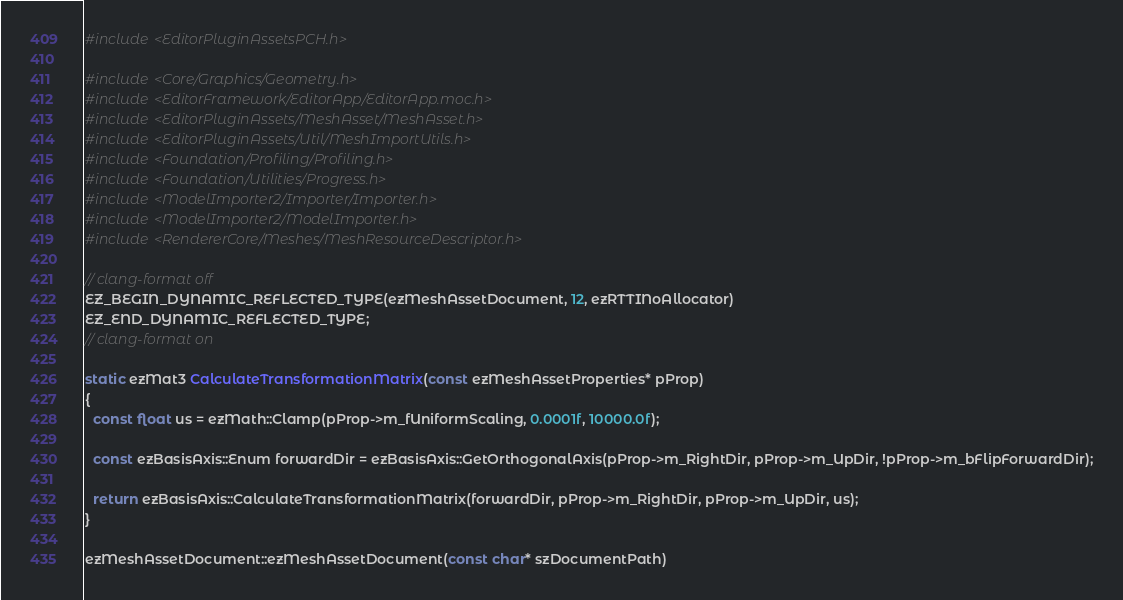<code> <loc_0><loc_0><loc_500><loc_500><_C++_>#include <EditorPluginAssetsPCH.h>

#include <Core/Graphics/Geometry.h>
#include <EditorFramework/EditorApp/EditorApp.moc.h>
#include <EditorPluginAssets/MeshAsset/MeshAsset.h>
#include <EditorPluginAssets/Util/MeshImportUtils.h>
#include <Foundation/Profiling/Profiling.h>
#include <Foundation/Utilities/Progress.h>
#include <ModelImporter2/Importer/Importer.h>
#include <ModelImporter2/ModelImporter.h>
#include <RendererCore/Meshes/MeshResourceDescriptor.h>

// clang-format off
EZ_BEGIN_DYNAMIC_REFLECTED_TYPE(ezMeshAssetDocument, 12, ezRTTINoAllocator)
EZ_END_DYNAMIC_REFLECTED_TYPE;
// clang-format on

static ezMat3 CalculateTransformationMatrix(const ezMeshAssetProperties* pProp)
{
  const float us = ezMath::Clamp(pProp->m_fUniformScaling, 0.0001f, 10000.0f);

  const ezBasisAxis::Enum forwardDir = ezBasisAxis::GetOrthogonalAxis(pProp->m_RightDir, pProp->m_UpDir, !pProp->m_bFlipForwardDir);

  return ezBasisAxis::CalculateTransformationMatrix(forwardDir, pProp->m_RightDir, pProp->m_UpDir, us);
}

ezMeshAssetDocument::ezMeshAssetDocument(const char* szDocumentPath)</code> 